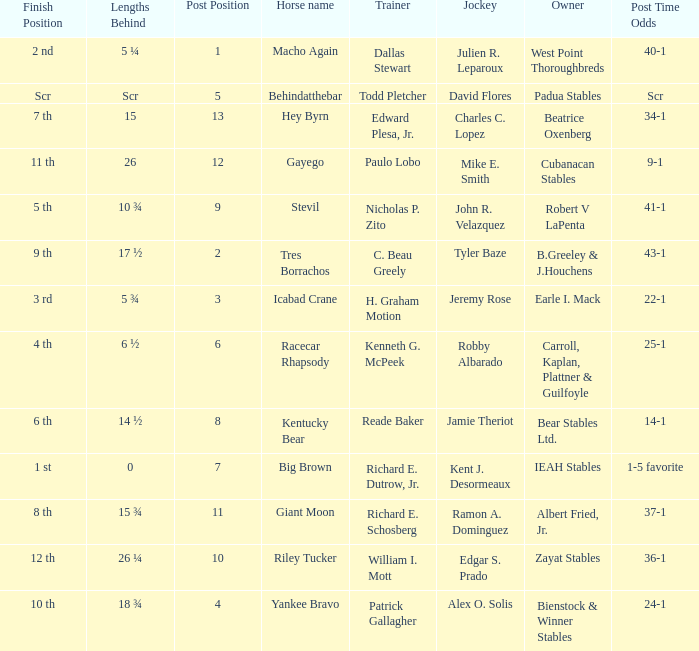Who is the owner of Icabad Crane? Earle I. Mack. 